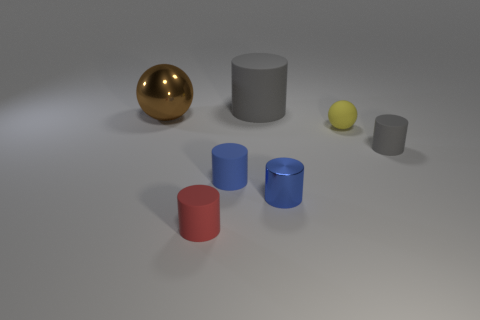Subtract all big cylinders. How many cylinders are left? 4 Subtract all purple balls. How many blue cylinders are left? 2 Add 3 balls. How many objects exist? 10 Subtract 3 cylinders. How many cylinders are left? 2 Subtract all gray cylinders. How many cylinders are left? 3 Subtract all cylinders. How many objects are left? 2 Subtract all cyan cylinders. Subtract all brown cubes. How many cylinders are left? 5 Subtract all matte spheres. Subtract all small gray cylinders. How many objects are left? 5 Add 5 large brown spheres. How many large brown spheres are left? 6 Add 2 yellow balls. How many yellow balls exist? 3 